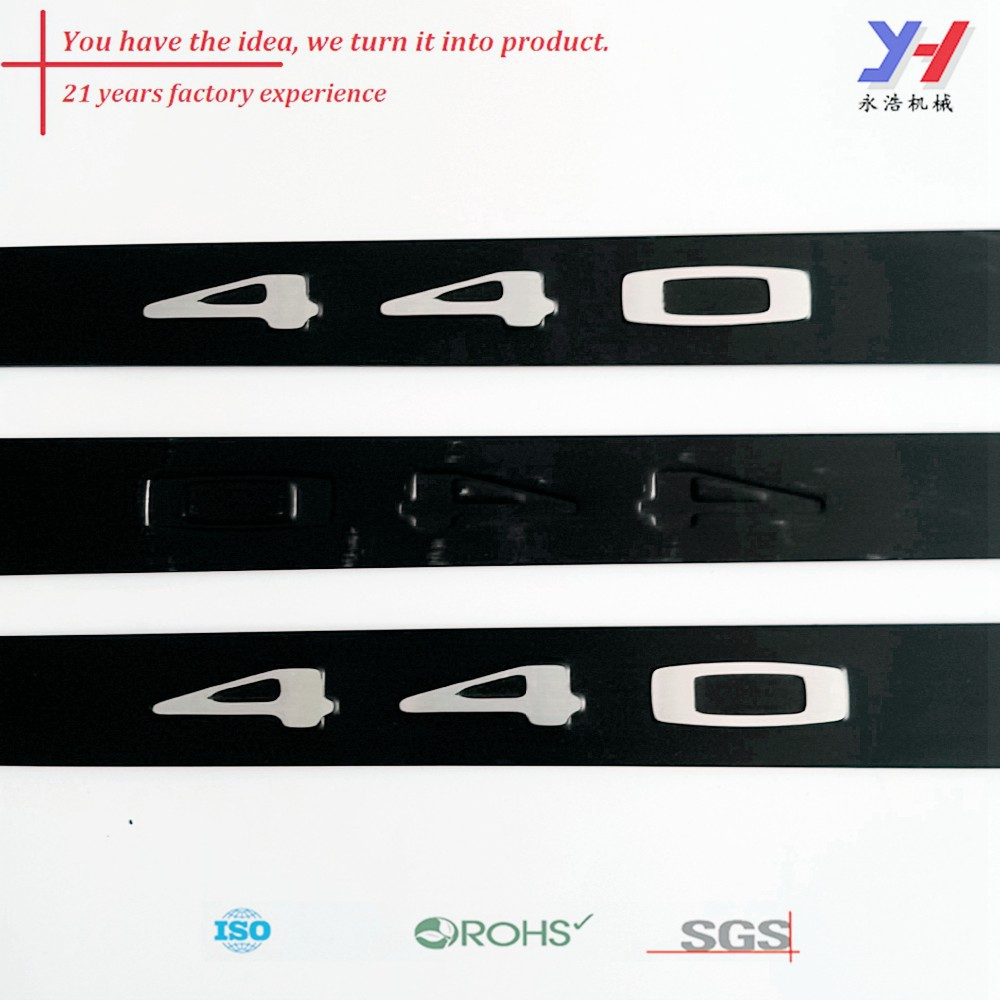Imagine if the number '40' was an avatar in a digital world. What would its characteristics be? If the number '40' were an avatar in a digital world, it would portray a character of resilience and sophistication. This avatar would likely be clad in a sleek, metallic armor that mirrors its reflective design in the real world, signifying strength and durability. It would possess attributes of innovation, wisdom from years of experience—the 21 years—and leadership within its virtual environment. This '40' avatar could act as a beacon of trust and excellence, symbolizing a peak or an aspirational figure within this digital landscape. 